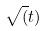<formula> <loc_0><loc_0><loc_500><loc_500>\sqrt { ( } t )</formula> 